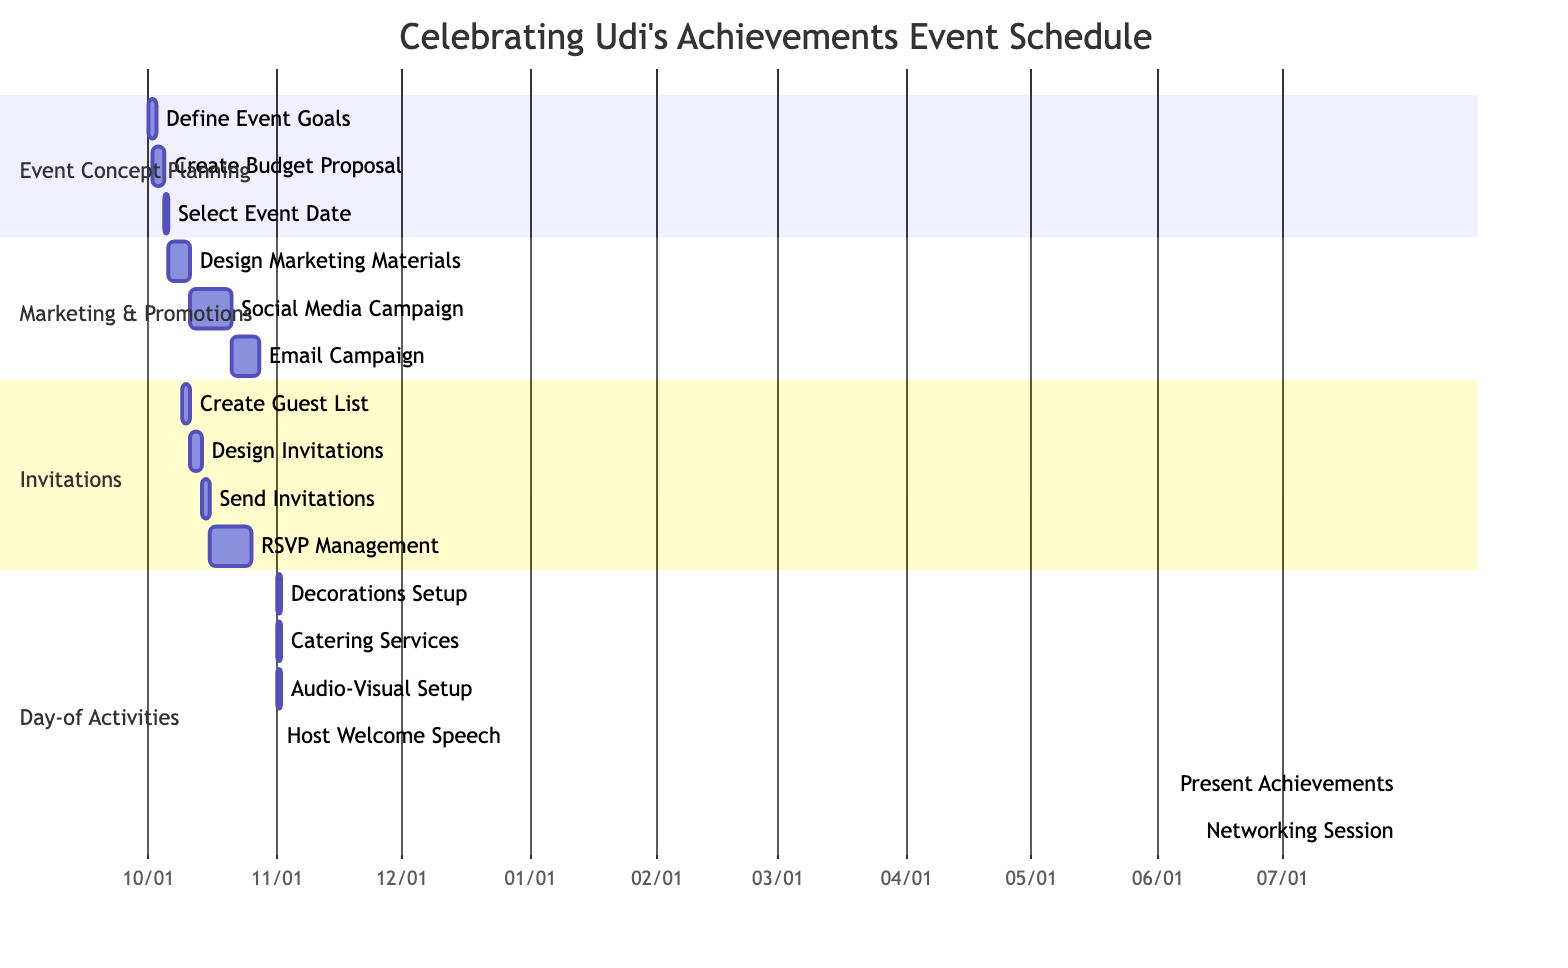What is the duration of the "Design Marketing Materials" task? The "Design Marketing Materials" task is represented in the "Marketing & Promotions" section. It has a specified duration of "5 days."
Answer: 5 days How many subtasks are there under the "Invitations" task? The "Invitations" task has four defined subtasks: "Create Guest List," "Design Invitations," "Send Invitations," and "RSVP Management." Therefore, the total is four subtasks.
Answer: 4 What is the start date for "Social Media Campaign"? The "Social Media Campaign" subtask is scheduled to start on "2023-10-11," as indicated in the Gantt chart under the "Marketing & Promotions" section.
Answer: 2023-10-11 Which subtask starts immediately after "Send Invitations"? After the "Send Invitations" subtask, the next one listed is "RSVP Management," which starts on "2023-10-16."
Answer: RSVP Management How is the "Host Welcome Speech" related to "Present Achievements"? The "Present Achievements" subtask begins immediately after the "Host Welcome Speech," which allows for a seamless flow of activities during the event as denoted by the "after" relation in the diagram.
Answer: after When will "Decorations Setup" and "Catering Services" occur? Both "Decorations Setup" and "Catering Services" are scheduled for the same date, "2023-11-01," under the "Day-of Activities" section.
Answer: 2023-11-01 What happens during the event at 09:30 on the day of the event? At 09:30 on the day of the event, the "Present Achievements" subtask is scheduled to take place for a duration of 1 hour following the "Host Welcome Speech."
Answer: Present Achievements How long will the "Networking Session" last? The "Networking Session" is indicated to last for 1 hour, as per the details outlined in the "Day-of Activities" section of the Gantt chart.
Answer: 1 hour What is the first task under "Day-of Activities"? According to the diagram, the first task listed under "Day-of Activities" is "Decorations Setup," which is scheduled for "2023-11-01."
Answer: Decorations Setup 